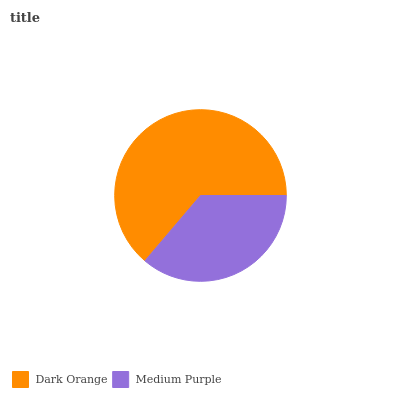Is Medium Purple the minimum?
Answer yes or no. Yes. Is Dark Orange the maximum?
Answer yes or no. Yes. Is Medium Purple the maximum?
Answer yes or no. No. Is Dark Orange greater than Medium Purple?
Answer yes or no. Yes. Is Medium Purple less than Dark Orange?
Answer yes or no. Yes. Is Medium Purple greater than Dark Orange?
Answer yes or no. No. Is Dark Orange less than Medium Purple?
Answer yes or no. No. Is Dark Orange the high median?
Answer yes or no. Yes. Is Medium Purple the low median?
Answer yes or no. Yes. Is Medium Purple the high median?
Answer yes or no. No. Is Dark Orange the low median?
Answer yes or no. No. 